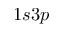<formula> <loc_0><loc_0><loc_500><loc_500>1 s 3 p</formula> 